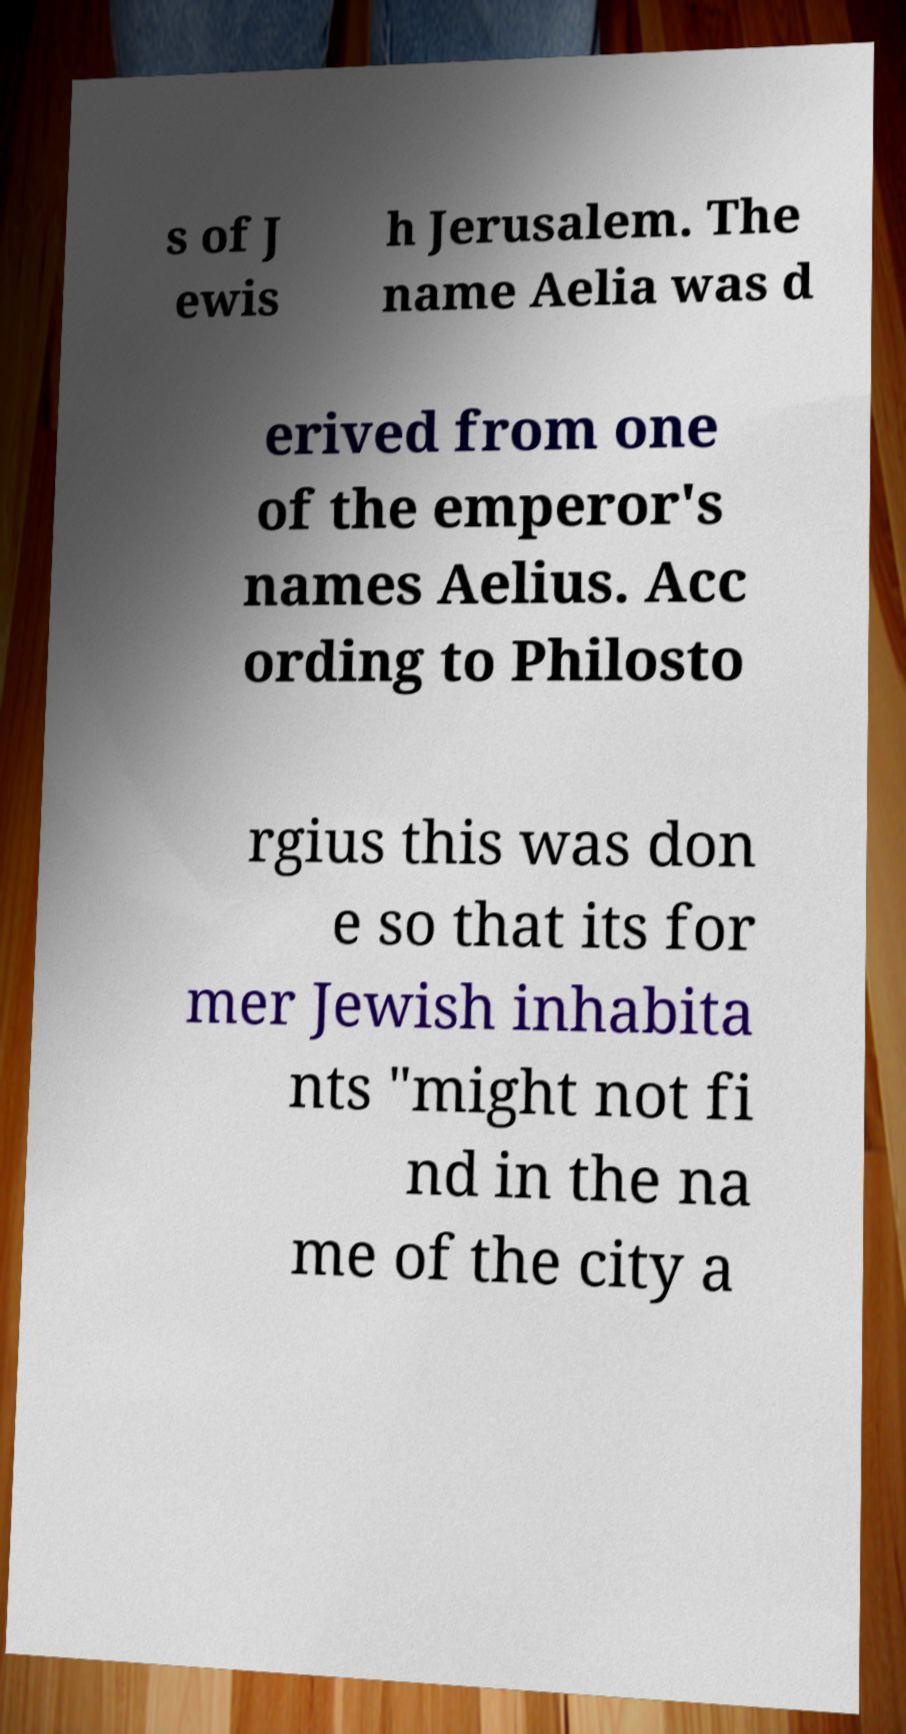For documentation purposes, I need the text within this image transcribed. Could you provide that? s of J ewis h Jerusalem. The name Aelia was d erived from one of the emperor's names Aelius. Acc ording to Philosto rgius this was don e so that its for mer Jewish inhabita nts "might not fi nd in the na me of the city a 